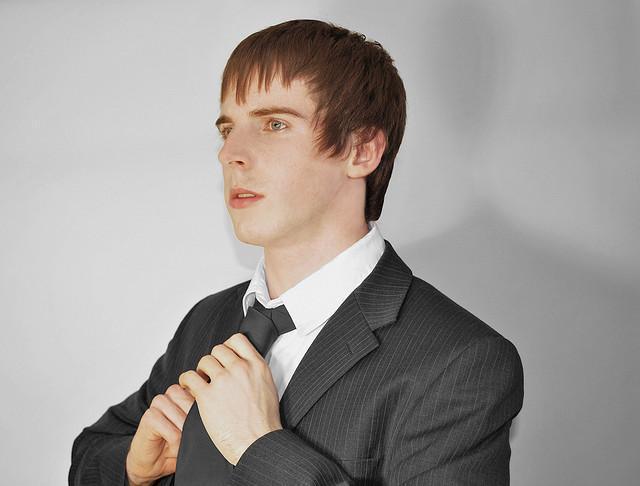How many ears do you see on the man?
Give a very brief answer. 1. How many people are in the pic?
Give a very brief answer. 1. 